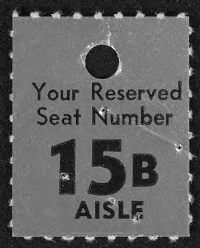Specify some key components in this picture. The reserved seat number is 15B. 